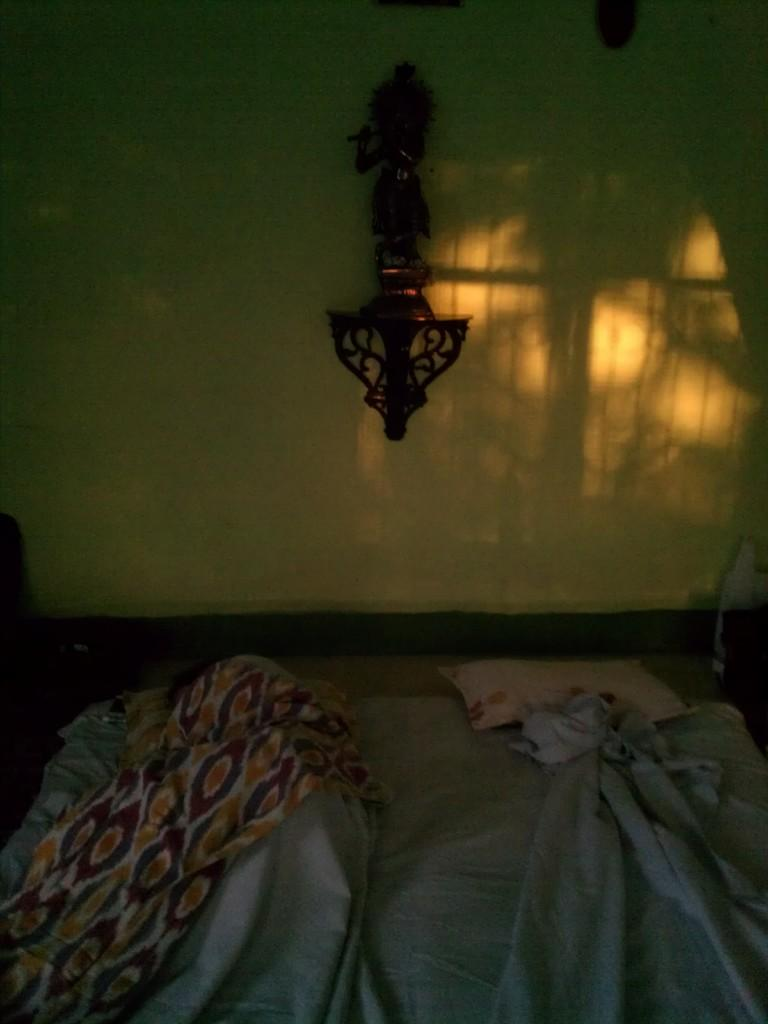What type of soft furnishings can be seen in the image? There are pillows and blankets in the image. Can you describe the object on the wall in the image? Unfortunately, the facts provided do not give any details about the object on the wall. What might be the purpose of the pillows and blankets in the image? The pillows and blankets may be used for comfort or warmth, as they are often associated with beds or seating areas. What type of paste is being used to create the curve on the rat in the image? There is no rat or curve present in the image, so it is not possible to answer that question. 